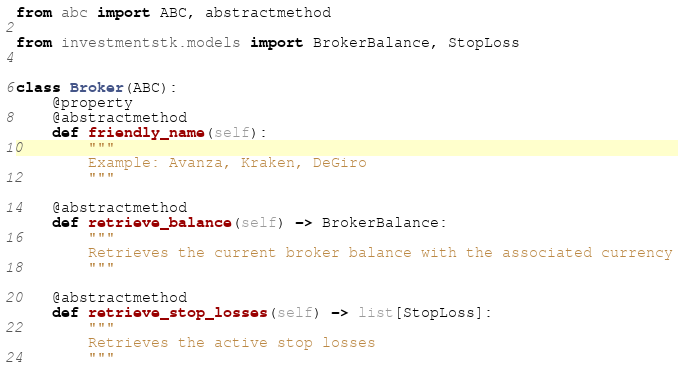<code> <loc_0><loc_0><loc_500><loc_500><_Python_>from abc import ABC, abstractmethod

from investmentstk.models import BrokerBalance, StopLoss


class Broker(ABC):
    @property
    @abstractmethod
    def friendly_name(self):
        """
        Example: Avanza, Kraken, DeGiro
        """

    @abstractmethod
    def retrieve_balance(self) -> BrokerBalance:
        """
        Retrieves the current broker balance with the associated currency
        """

    @abstractmethod
    def retrieve_stop_losses(self) -> list[StopLoss]:
        """
        Retrieves the active stop losses
        """
</code> 